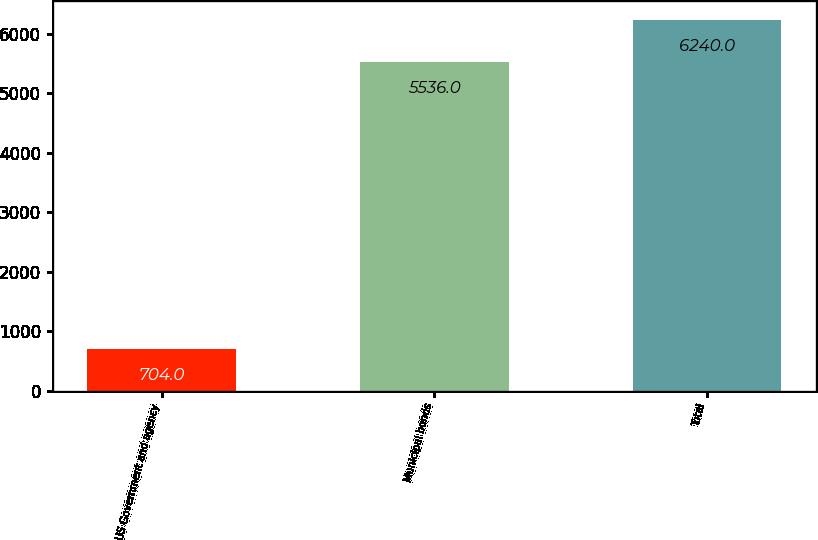Convert chart to OTSL. <chart><loc_0><loc_0><loc_500><loc_500><bar_chart><fcel>US Government and agency<fcel>Municipal bonds<fcel>Total<nl><fcel>704<fcel>5536<fcel>6240<nl></chart> 